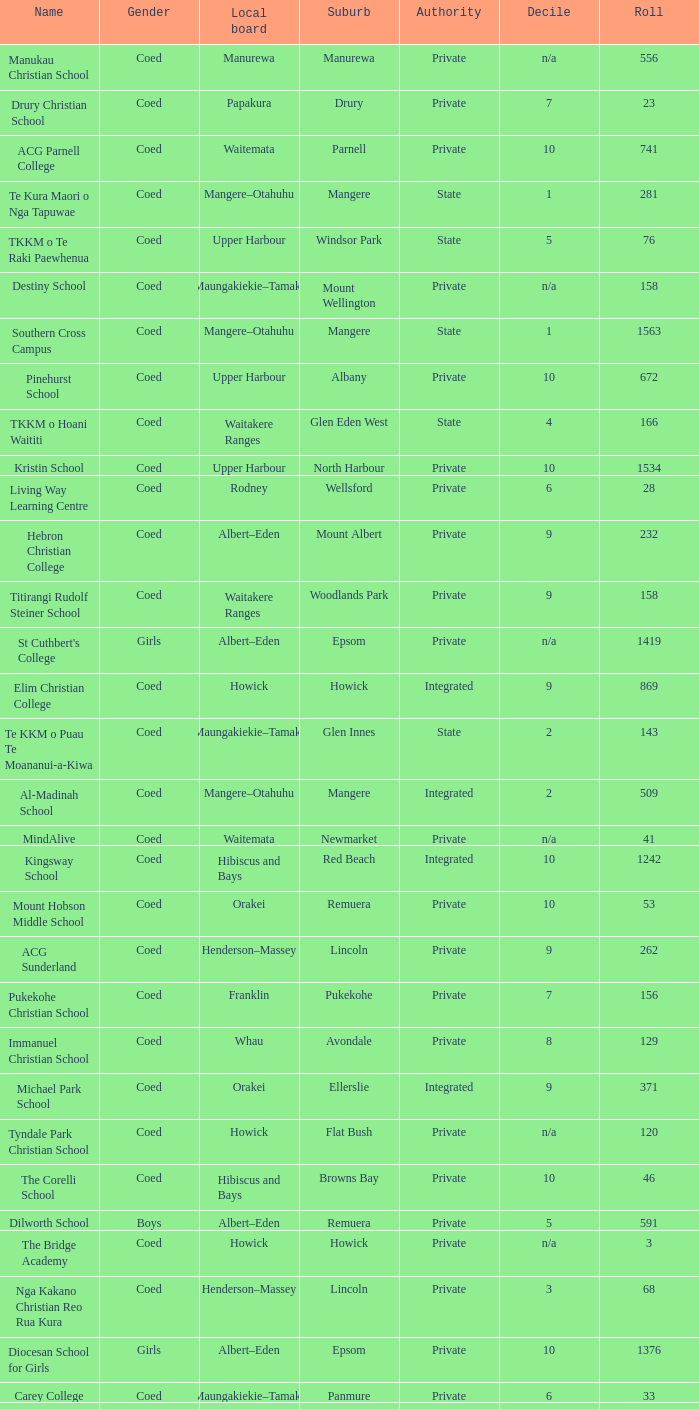What name shows as private authority and hibiscus and bays local board ? The Corelli School. 